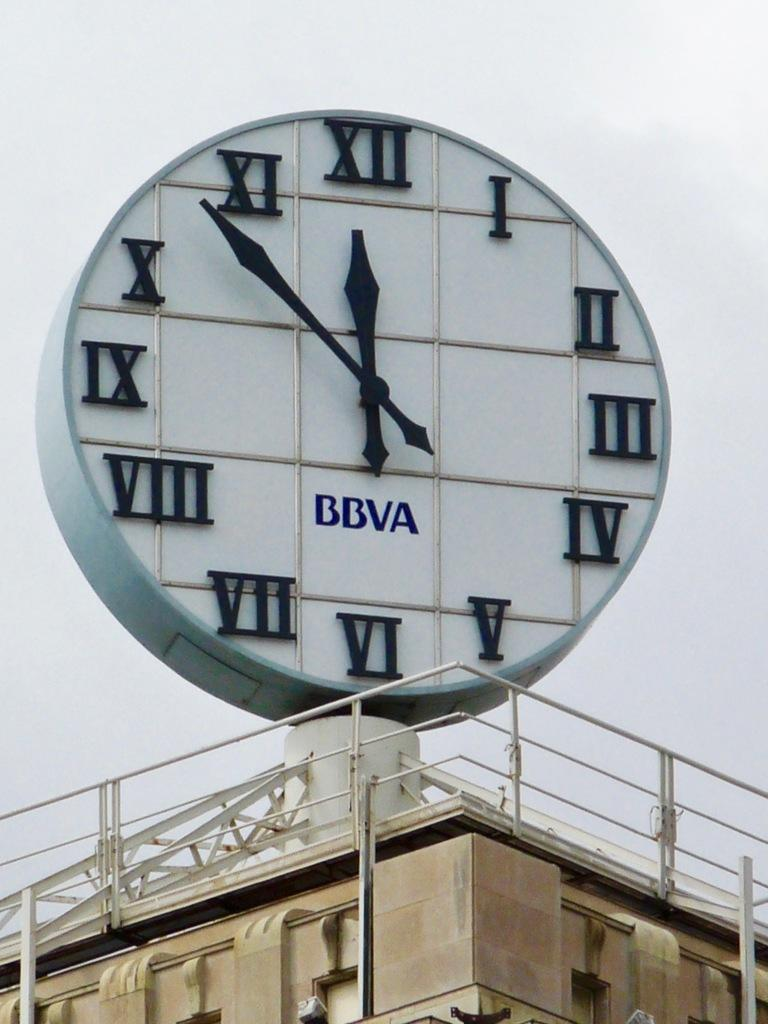<image>
Share a concise interpretation of the image provided. A big BBVA outdoor clack show the time of 11:53. 